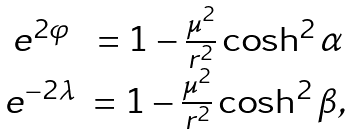Convert formula to latex. <formula><loc_0><loc_0><loc_500><loc_500>\begin{array} { c c } e ^ { 2 \varphi } & = 1 - \frac { \mu ^ { 2 } } { r ^ { 2 } } \cosh ^ { 2 } \alpha \\ e ^ { - 2 \lambda } & = 1 - \frac { \mu ^ { 2 } } { r ^ { 2 } } \cosh ^ { 2 } \beta , \end{array}</formula> 